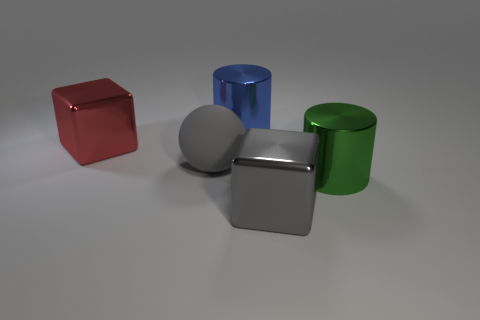Add 1 cylinders. How many objects exist? 6 Subtract all cylinders. How many objects are left? 3 Add 4 gray objects. How many gray objects are left? 6 Add 5 large cubes. How many large cubes exist? 7 Subtract 0 purple cylinders. How many objects are left? 5 Subtract all blue metal cylinders. Subtract all blue metal objects. How many objects are left? 3 